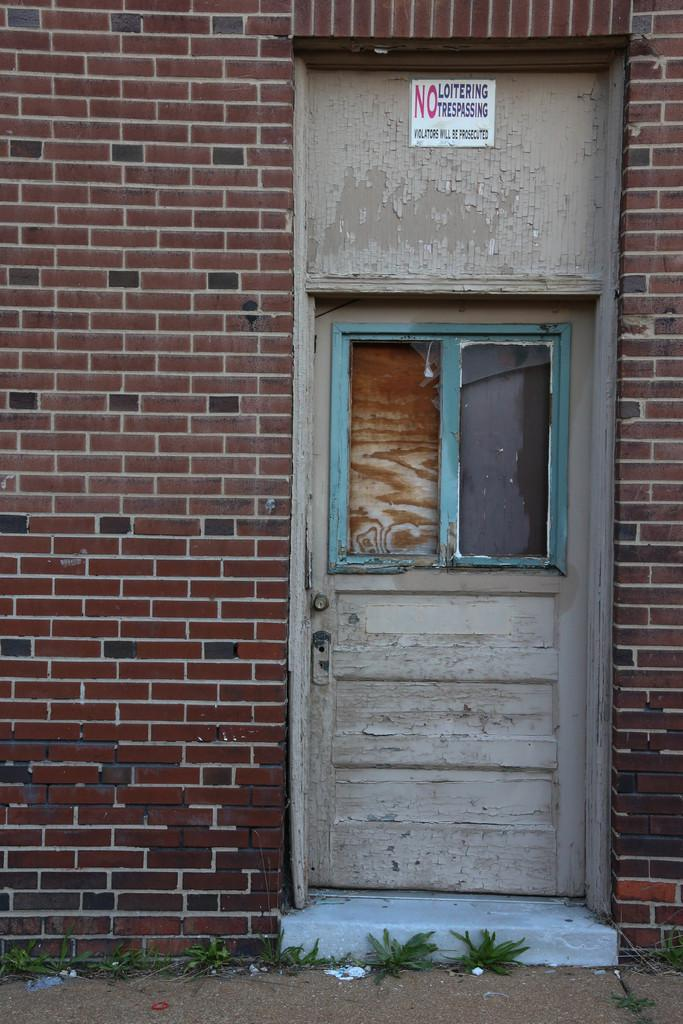What is the main structure in the center of the image? There is a house in the center of the image. What features can be seen on the house? The house has a door and a window. What type of terrain is visible at the bottom of the image? There is sand and grass at the bottom of the image. How many letters are being transported by the twig in the image? There is no twig or letters present in the image. 